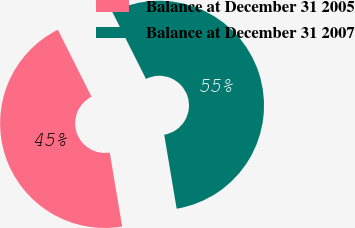<chart> <loc_0><loc_0><loc_500><loc_500><pie_chart><fcel>Balance at December 31 2005<fcel>Balance at December 31 2007<nl><fcel>45.24%<fcel>54.76%<nl></chart> 